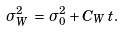<formula> <loc_0><loc_0><loc_500><loc_500>\sigma _ { W } ^ { 2 } \, = \, \sigma _ { 0 } ^ { 2 } + C _ { W } \, t .</formula> 